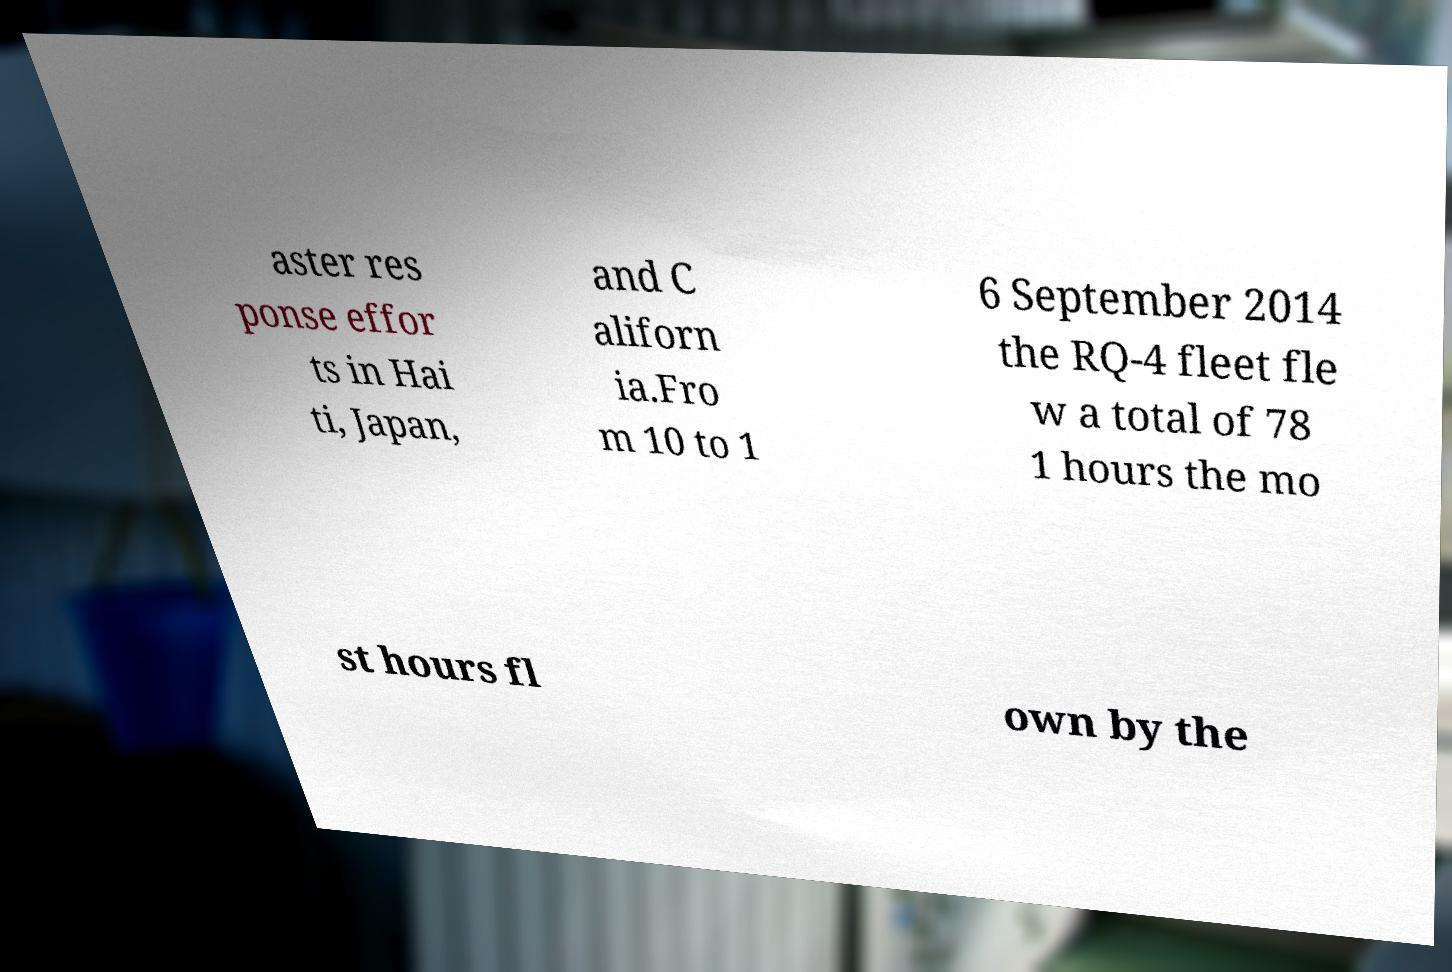Could you assist in decoding the text presented in this image and type it out clearly? aster res ponse effor ts in Hai ti, Japan, and C aliforn ia.Fro m 10 to 1 6 September 2014 the RQ-4 fleet fle w a total of 78 1 hours the mo st hours fl own by the 